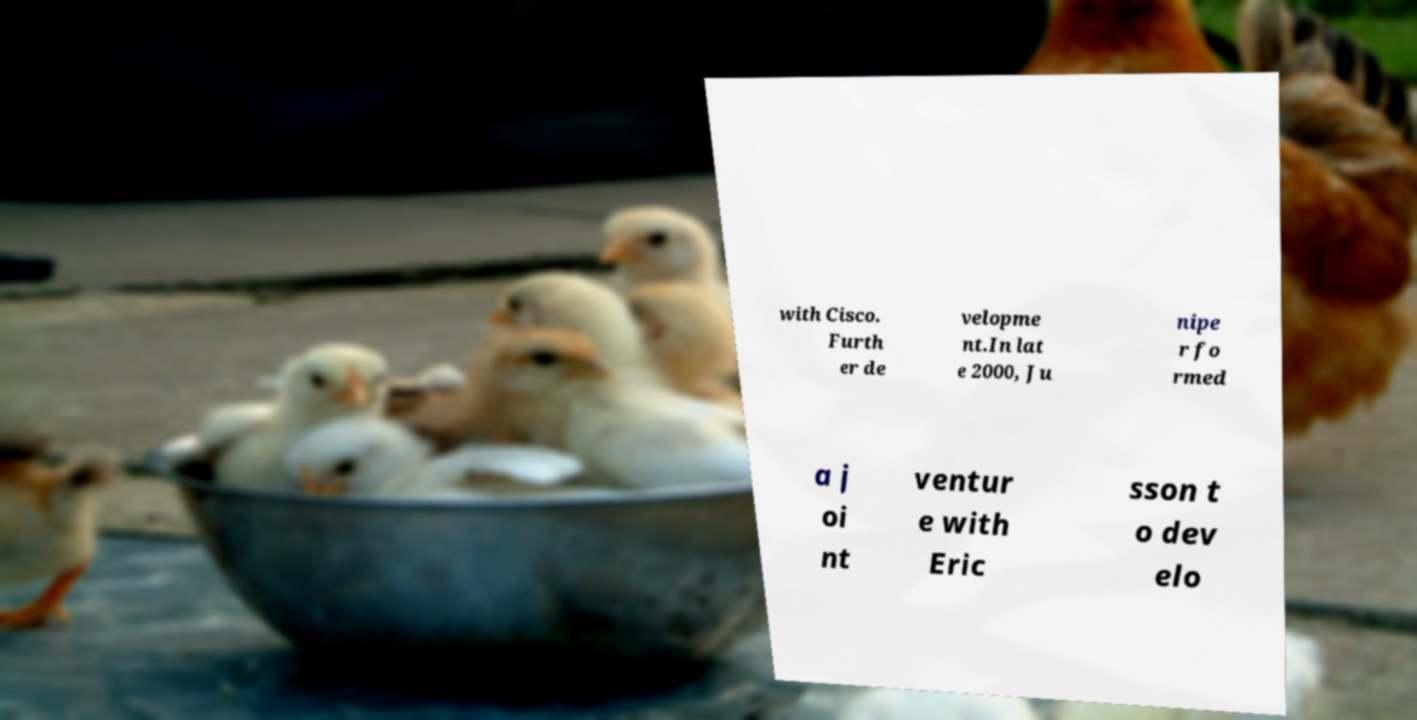For documentation purposes, I need the text within this image transcribed. Could you provide that? with Cisco. Furth er de velopme nt.In lat e 2000, Ju nipe r fo rmed a j oi nt ventur e with Eric sson t o dev elo 